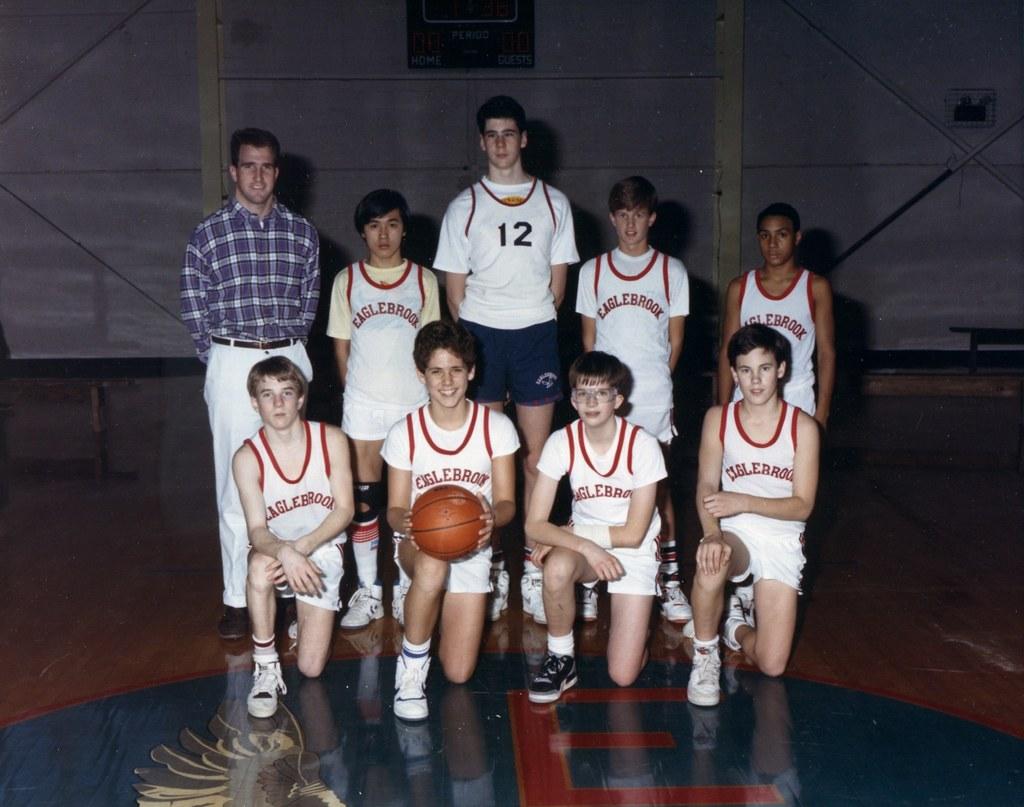What number is the tallest one?
Provide a succinct answer. 12. 